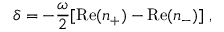<formula> <loc_0><loc_0><loc_500><loc_500>\delta = - \frac { \omega } { 2 } [ R e ( n _ { + } ) - R e ( n _ { - } ) ] \, ,</formula> 